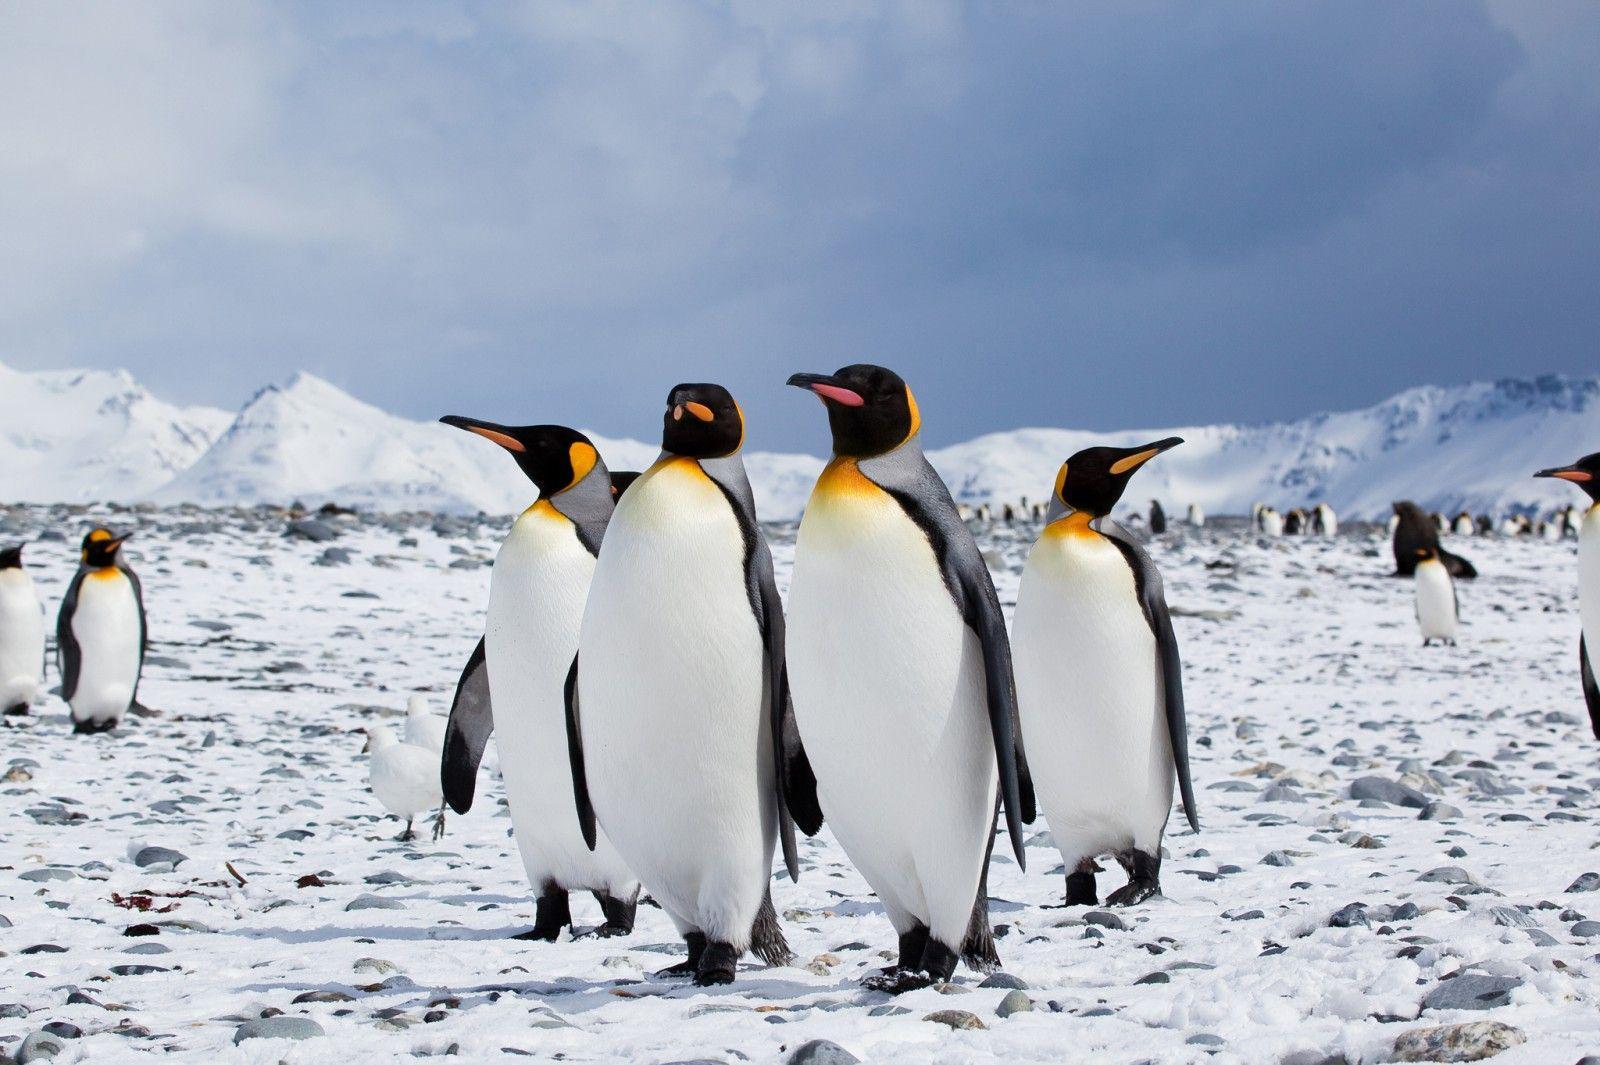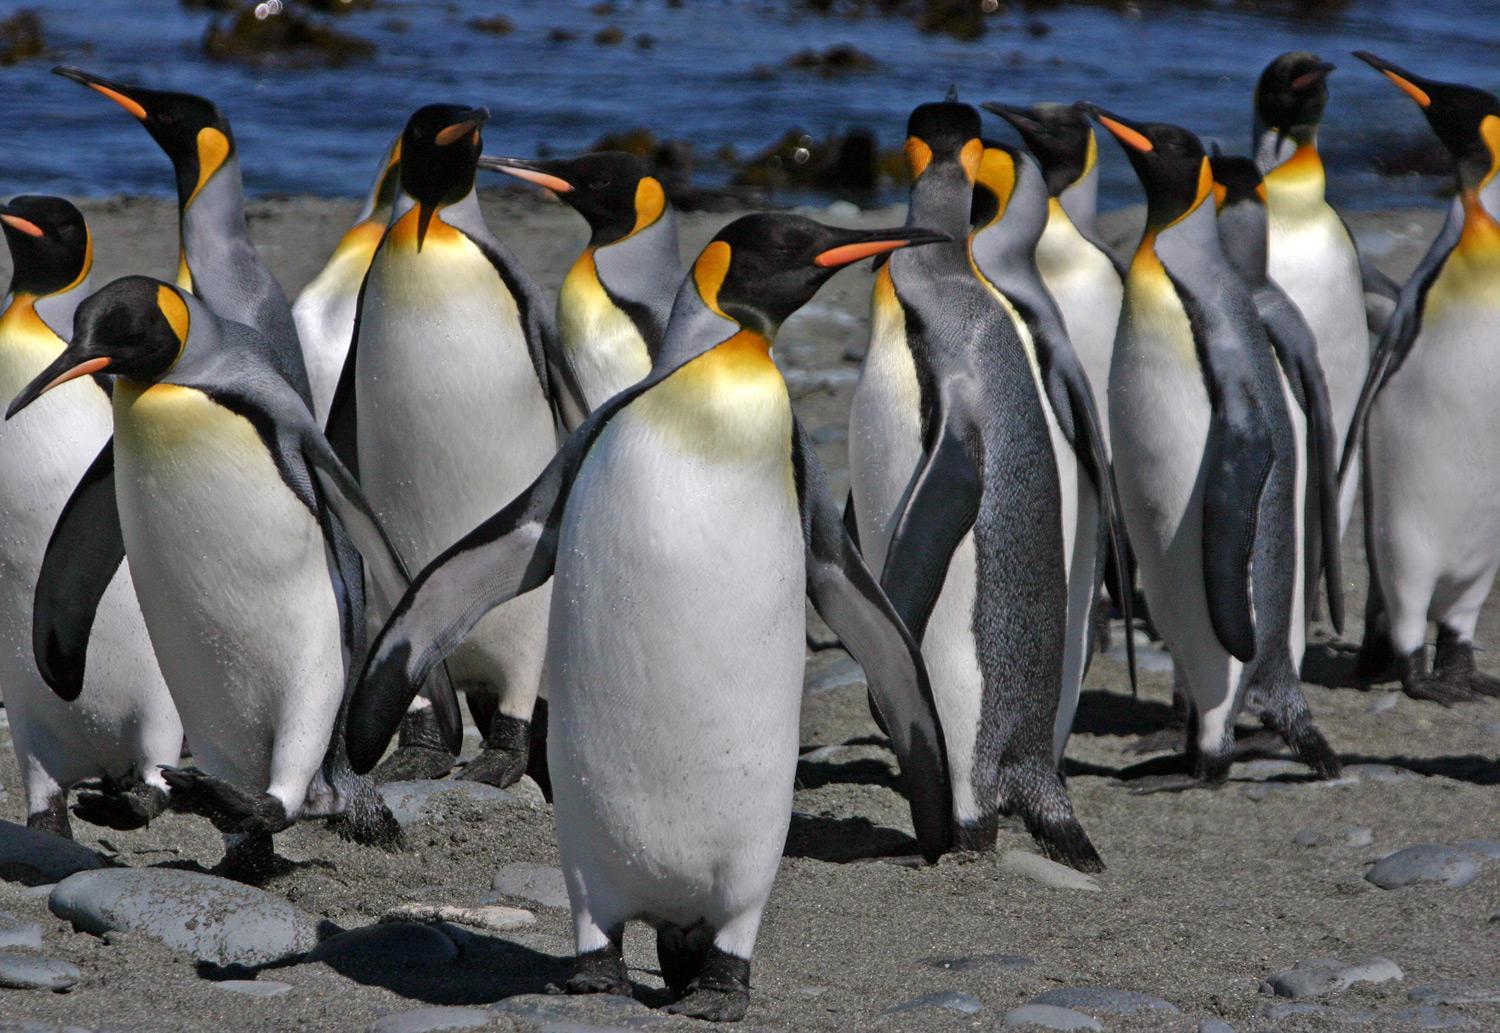The first image is the image on the left, the second image is the image on the right. Examine the images to the left and right. Is the description "There are two penguins in the image pair." accurate? Answer yes or no. No. The first image is the image on the left, the second image is the image on the right. Assess this claim about the two images: "Each image contains a single penguin, and the penguins share similar body poses.". Correct or not? Answer yes or no. No. The first image is the image on the left, the second image is the image on the right. Examine the images to the left and right. Is the description "The ground is visible in the image on the right." accurate? Answer yes or no. Yes. 